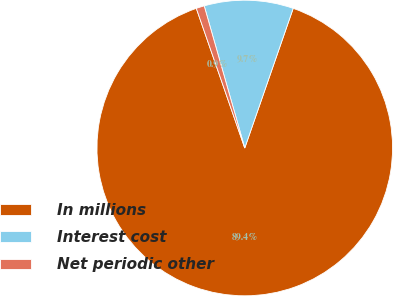<chart> <loc_0><loc_0><loc_500><loc_500><pie_chart><fcel>In millions<fcel>Interest cost<fcel>Net periodic other<nl><fcel>89.37%<fcel>9.74%<fcel>0.89%<nl></chart> 